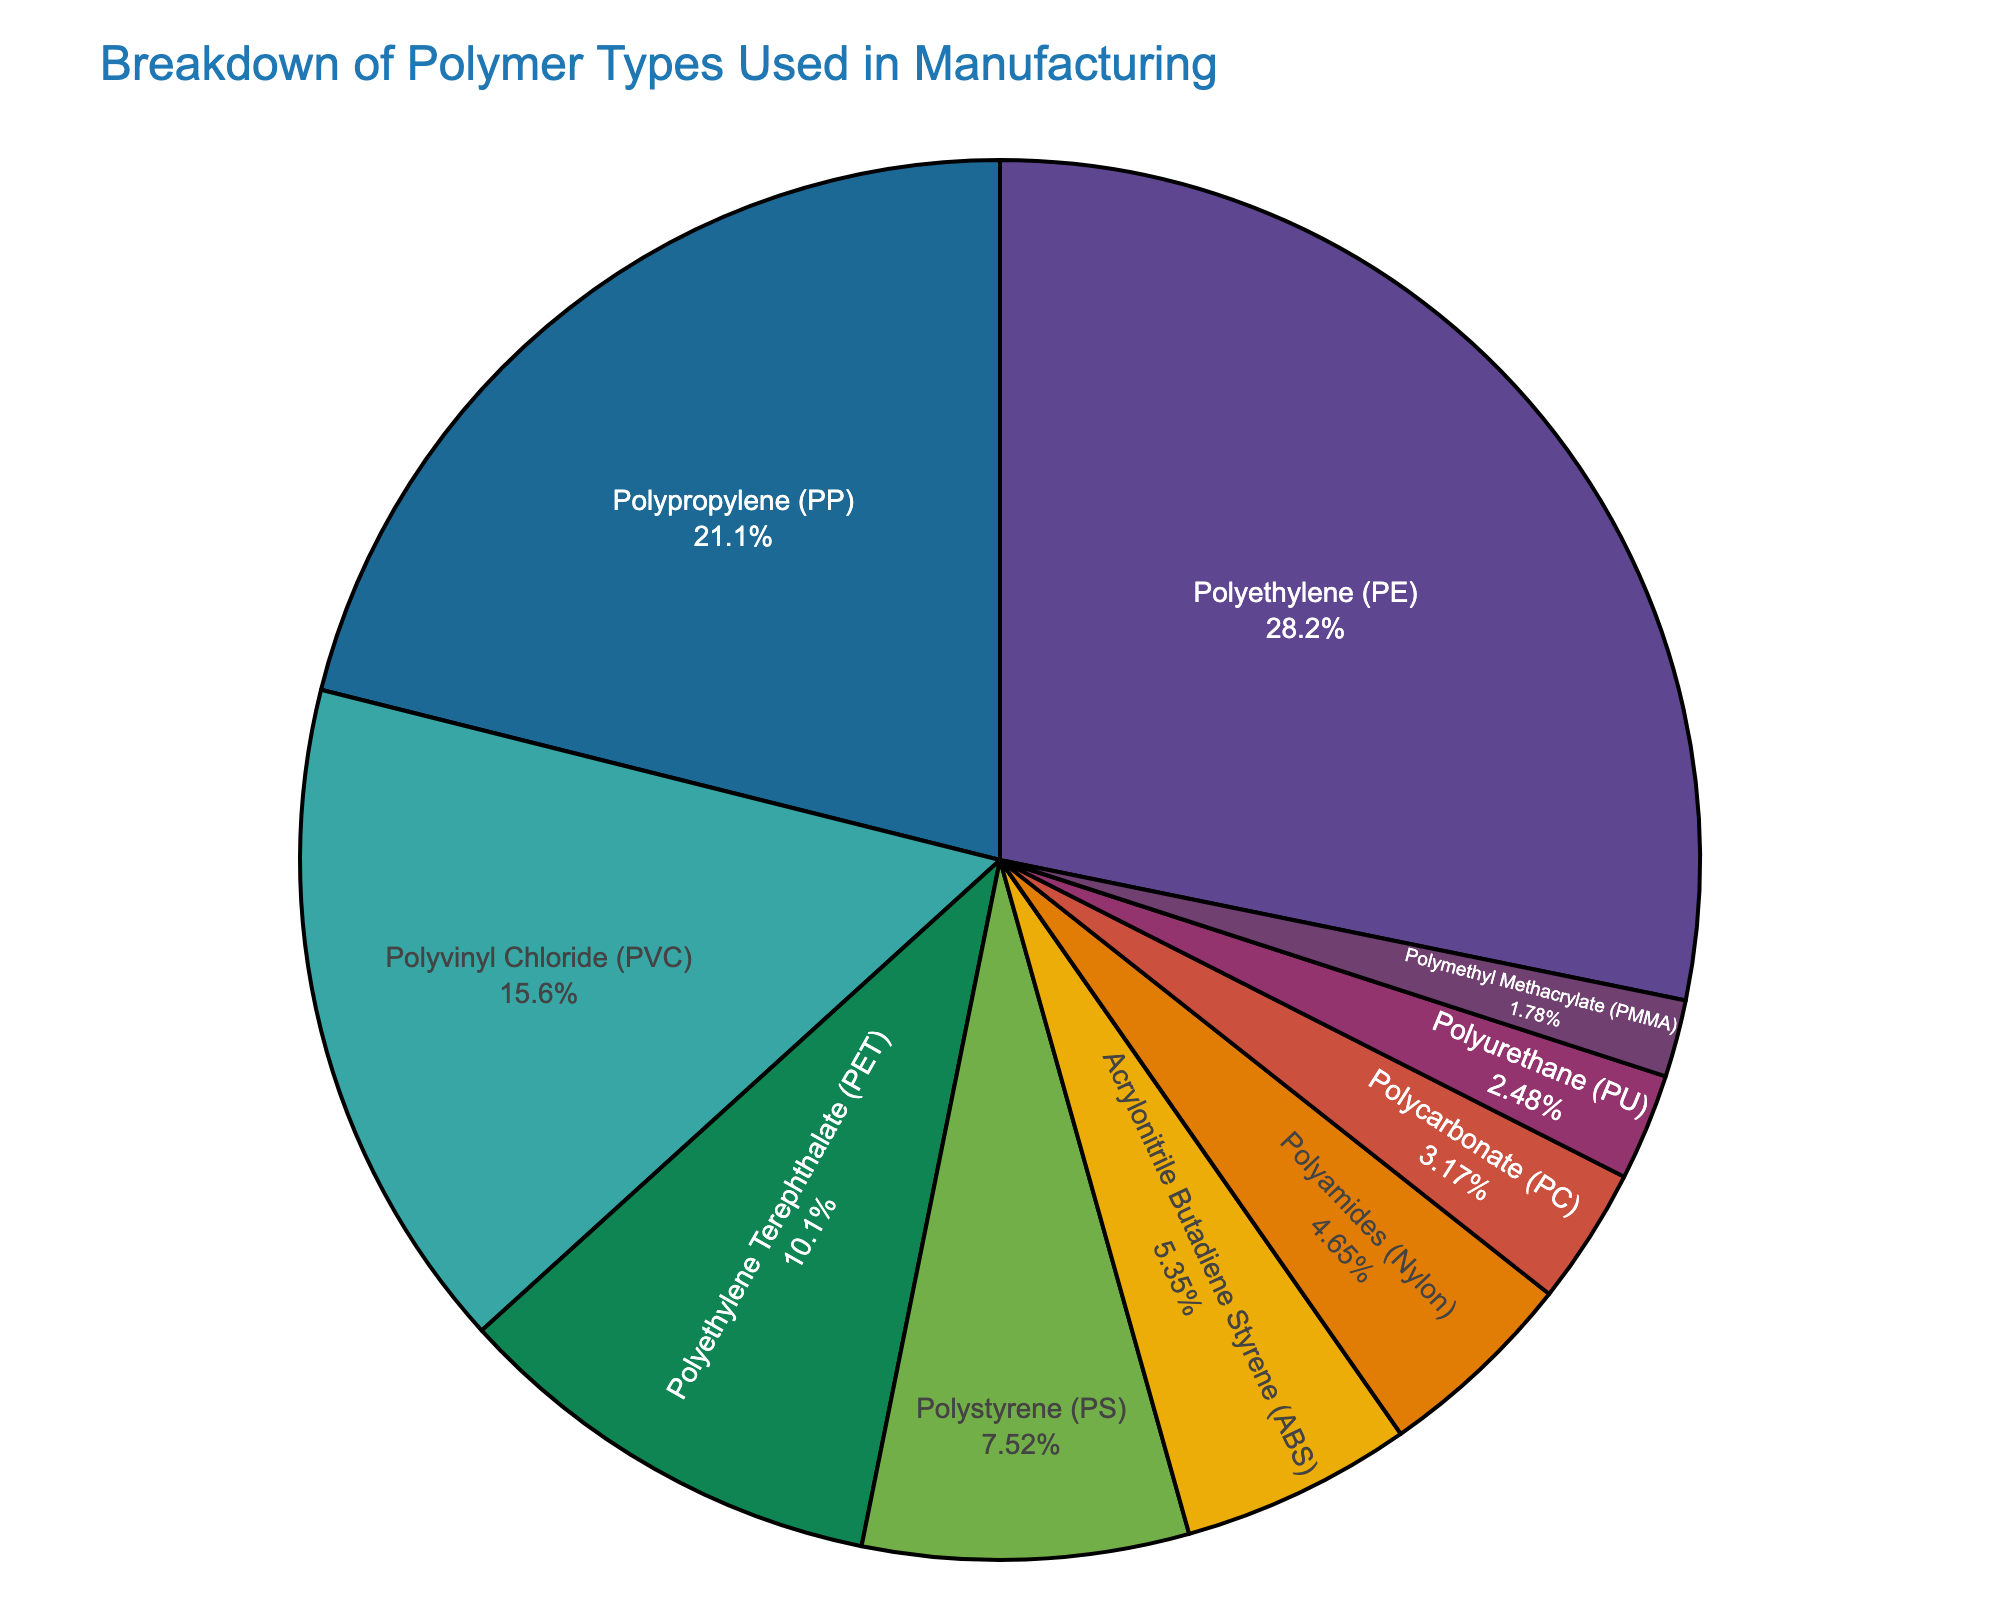What percentage of the total polymer types used in manufacturing is made up of Polyethylene (PE) and Polypropylene (PP)? To find the combined percentage of Polyethylene (PE) and Polypropylene (PP), add their individual percentages. PE is 28.5% and PP is 21.3%. Therefore, 28.5% + 21.3% = 49.8%.
Answer: 49.8% Which polymer type has the lowest percentage of usage in manufacturing? The polymer type with the lowest percentage is the one with the smallest value. From the data, Polymethyl Methacrylate (PMMA) has the lowest percentage at 1.8%.
Answer: Polymethyl Methacrylate (PMMA) What is the difference in usage percentage between Polyethylene Terephthalate (PET) and Polystyrene (PS)? Subtract the percentage of Polystyrene (PS) from the percentage of Polyethylene Terephthalate (PET). PET is 10.2% and PS is 7.6%, so 10.2% - 7.6% = 2.6%.
Answer: 2.6% How much more prevalent is Polyethylene (PE) compared to Acrylonitrile Butadiene Styrene (ABS)? Subtract the percentage of ABS from the percentage of PE. PE is 28.5% and ABS is 5.4%, so 28.5% - 5.4% = 23.1%.
Answer: 23.1% What is the combined percentage of Polycarbonate (PC), Polyurethane (PU), and Polymethyl Methacrylate (PMMA)? Add the percentages of PC, PU, and PMMA. PC is 3.2%, PU is 2.5%, and PMMA is 1.8%. Therefore, 3.2% + 2.5% + 1.8% = 7.5%.
Answer: 7.5% Which polymer types combined make up more than 50% of the total usage? Identify the polymers whose combined percentages exceed 50%. Polyethylene (PE) is 28.5% and Polypropylene (PP) is 21.3%. Their sum is 28.5% + 21.3% = 49.8%. Adding the next highest, Polyvinyl Chloride (PVC) with 15.8%, makes the total 49.8% + 15.8% = 65.6%, which is more than 50%.
Answer: Polyethylene (PE), Polypropylene (PP), Polyvinyl Chloride (PVC) Which polymer type has a higher percentage of usage: Polyamides (Nylon) or Polycarbonate (PC)? Compare the percentages of Polyamides (Nylon) and Polycarbonate (PC). Polyamides (Nylon) has 4.7%, and Polycarbonate (PC) has 3.2%. Since 4.7% is greater than 3.2%, Polyamides (Nylon) has a higher percentage.
Answer: Polyamides (Nylon) What is the total percentage of the two most used polymer types? Sum the percentages of the two most used polymer types, Polyethylene (PE) and Polypropylene (PP). PE is 28.5%, and PP is 21.3%. Therefore, 28.5% + 21.3% = 49.8%.
Answer: 49.8% How does the usage percentage of Polyvinyl Chloride (PVC) compare to Polyethylene Terephthalate (PET) and Polystyrene (PS) combined? Compare the percentage of PVC with the combined percentage of PET and PS. PVC is 15.8%. PET is 10.2%, and PS is 7.6%. Their combined percentage is 10.2% + 7.6% = 17.8%. Since 17.8% is greater than 15.8%, PVC is less than the combined PET and PS.
Answer: Less 